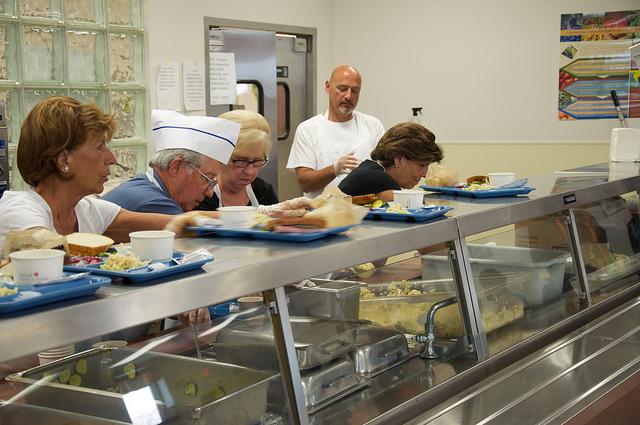Where is this?
Quick response, please. Cafeteria. What shape are the small windows?
Write a very short answer. Square. Do the workers appear to be following basic food safety protocol?
Keep it brief. Yes. How many workers are there?
Short answer required. 5. What color are the trays?
Give a very brief answer. Blue. What food are they serving?
Keep it brief. Lunch. Is this a recommended place for dieters to dine?
Keep it brief. No. What color is the bold man's shirt?
Concise answer only. White. What are they making?
Keep it brief. Lunch. 